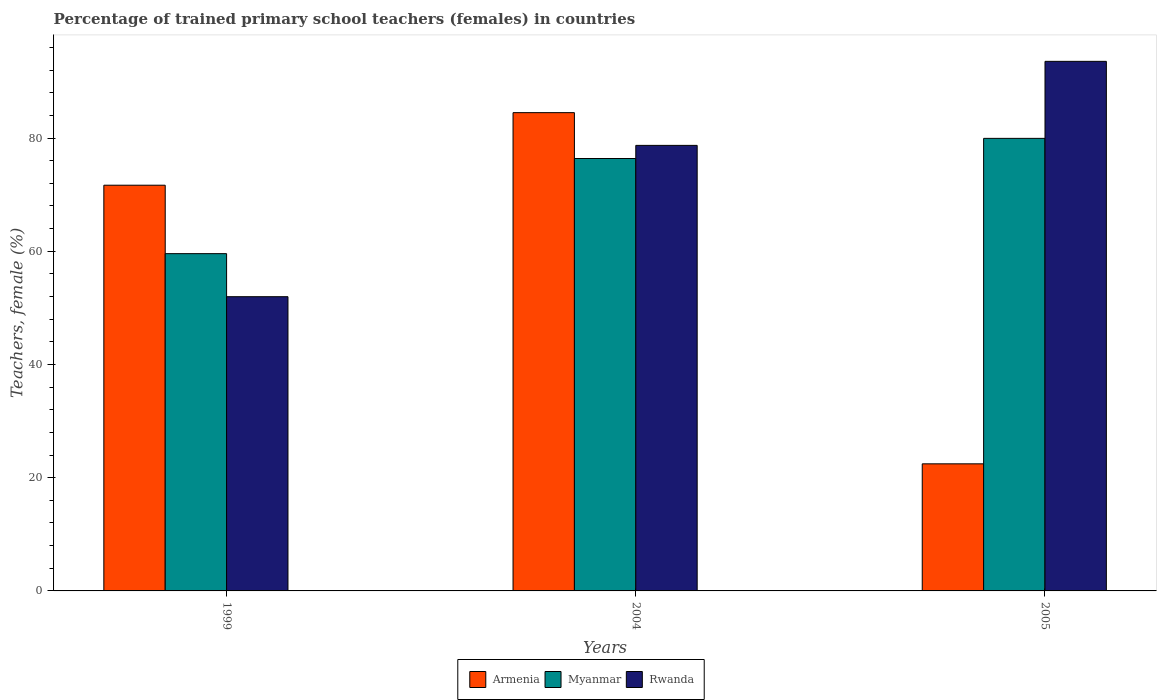How many different coloured bars are there?
Your answer should be compact. 3. Are the number of bars per tick equal to the number of legend labels?
Offer a very short reply. Yes. Are the number of bars on each tick of the X-axis equal?
Your response must be concise. Yes. How many bars are there on the 3rd tick from the left?
Provide a short and direct response. 3. What is the label of the 3rd group of bars from the left?
Provide a short and direct response. 2005. In how many cases, is the number of bars for a given year not equal to the number of legend labels?
Your answer should be compact. 0. What is the percentage of trained primary school teachers (females) in Armenia in 2005?
Provide a succinct answer. 22.45. Across all years, what is the maximum percentage of trained primary school teachers (females) in Armenia?
Give a very brief answer. 84.48. Across all years, what is the minimum percentage of trained primary school teachers (females) in Rwanda?
Provide a succinct answer. 51.97. In which year was the percentage of trained primary school teachers (females) in Rwanda maximum?
Offer a very short reply. 2005. In which year was the percentage of trained primary school teachers (females) in Myanmar minimum?
Provide a succinct answer. 1999. What is the total percentage of trained primary school teachers (females) in Armenia in the graph?
Your response must be concise. 178.6. What is the difference between the percentage of trained primary school teachers (females) in Myanmar in 1999 and that in 2004?
Make the answer very short. -16.81. What is the difference between the percentage of trained primary school teachers (females) in Rwanda in 2005 and the percentage of trained primary school teachers (females) in Armenia in 2004?
Make the answer very short. 9.06. What is the average percentage of trained primary school teachers (females) in Rwanda per year?
Make the answer very short. 74.74. In the year 2004, what is the difference between the percentage of trained primary school teachers (females) in Armenia and percentage of trained primary school teachers (females) in Rwanda?
Ensure brevity in your answer.  5.78. In how many years, is the percentage of trained primary school teachers (females) in Armenia greater than 20 %?
Keep it short and to the point. 3. What is the ratio of the percentage of trained primary school teachers (females) in Armenia in 1999 to that in 2004?
Keep it short and to the point. 0.85. Is the percentage of trained primary school teachers (females) in Armenia in 1999 less than that in 2005?
Your response must be concise. No. What is the difference between the highest and the second highest percentage of trained primary school teachers (females) in Myanmar?
Your response must be concise. 3.56. What is the difference between the highest and the lowest percentage of trained primary school teachers (females) in Myanmar?
Keep it short and to the point. 20.36. What does the 2nd bar from the left in 1999 represents?
Ensure brevity in your answer.  Myanmar. What does the 3rd bar from the right in 1999 represents?
Your answer should be compact. Armenia. How many bars are there?
Your answer should be compact. 9. How many legend labels are there?
Give a very brief answer. 3. What is the title of the graph?
Offer a terse response. Percentage of trained primary school teachers (females) in countries. Does "Macedonia" appear as one of the legend labels in the graph?
Your response must be concise. No. What is the label or title of the Y-axis?
Make the answer very short. Teachers, female (%). What is the Teachers, female (%) of Armenia in 1999?
Offer a very short reply. 71.67. What is the Teachers, female (%) of Myanmar in 1999?
Keep it short and to the point. 59.58. What is the Teachers, female (%) of Rwanda in 1999?
Ensure brevity in your answer.  51.97. What is the Teachers, female (%) in Armenia in 2004?
Give a very brief answer. 84.48. What is the Teachers, female (%) in Myanmar in 2004?
Offer a terse response. 76.38. What is the Teachers, female (%) in Rwanda in 2004?
Provide a succinct answer. 78.7. What is the Teachers, female (%) of Armenia in 2005?
Keep it short and to the point. 22.45. What is the Teachers, female (%) of Myanmar in 2005?
Your answer should be very brief. 79.94. What is the Teachers, female (%) of Rwanda in 2005?
Ensure brevity in your answer.  93.54. Across all years, what is the maximum Teachers, female (%) of Armenia?
Your answer should be compact. 84.48. Across all years, what is the maximum Teachers, female (%) in Myanmar?
Keep it short and to the point. 79.94. Across all years, what is the maximum Teachers, female (%) in Rwanda?
Make the answer very short. 93.54. Across all years, what is the minimum Teachers, female (%) in Armenia?
Offer a terse response. 22.45. Across all years, what is the minimum Teachers, female (%) of Myanmar?
Your answer should be very brief. 59.58. Across all years, what is the minimum Teachers, female (%) in Rwanda?
Your response must be concise. 51.97. What is the total Teachers, female (%) of Armenia in the graph?
Provide a short and direct response. 178.6. What is the total Teachers, female (%) in Myanmar in the graph?
Keep it short and to the point. 215.9. What is the total Teachers, female (%) of Rwanda in the graph?
Ensure brevity in your answer.  224.22. What is the difference between the Teachers, female (%) of Armenia in 1999 and that in 2004?
Provide a succinct answer. -12.82. What is the difference between the Teachers, female (%) of Myanmar in 1999 and that in 2004?
Provide a short and direct response. -16.81. What is the difference between the Teachers, female (%) of Rwanda in 1999 and that in 2004?
Keep it short and to the point. -26.73. What is the difference between the Teachers, female (%) in Armenia in 1999 and that in 2005?
Ensure brevity in your answer.  49.22. What is the difference between the Teachers, female (%) in Myanmar in 1999 and that in 2005?
Provide a succinct answer. -20.36. What is the difference between the Teachers, female (%) of Rwanda in 1999 and that in 2005?
Make the answer very short. -41.57. What is the difference between the Teachers, female (%) in Armenia in 2004 and that in 2005?
Provide a succinct answer. 62.03. What is the difference between the Teachers, female (%) in Myanmar in 2004 and that in 2005?
Your answer should be compact. -3.56. What is the difference between the Teachers, female (%) of Rwanda in 2004 and that in 2005?
Your response must be concise. -14.84. What is the difference between the Teachers, female (%) of Armenia in 1999 and the Teachers, female (%) of Myanmar in 2004?
Make the answer very short. -4.72. What is the difference between the Teachers, female (%) of Armenia in 1999 and the Teachers, female (%) of Rwanda in 2004?
Provide a short and direct response. -7.03. What is the difference between the Teachers, female (%) in Myanmar in 1999 and the Teachers, female (%) in Rwanda in 2004?
Your response must be concise. -19.12. What is the difference between the Teachers, female (%) of Armenia in 1999 and the Teachers, female (%) of Myanmar in 2005?
Provide a short and direct response. -8.27. What is the difference between the Teachers, female (%) in Armenia in 1999 and the Teachers, female (%) in Rwanda in 2005?
Your response must be concise. -21.88. What is the difference between the Teachers, female (%) of Myanmar in 1999 and the Teachers, female (%) of Rwanda in 2005?
Provide a short and direct response. -33.97. What is the difference between the Teachers, female (%) of Armenia in 2004 and the Teachers, female (%) of Myanmar in 2005?
Your response must be concise. 4.54. What is the difference between the Teachers, female (%) in Armenia in 2004 and the Teachers, female (%) in Rwanda in 2005?
Keep it short and to the point. -9.06. What is the difference between the Teachers, female (%) of Myanmar in 2004 and the Teachers, female (%) of Rwanda in 2005?
Provide a succinct answer. -17.16. What is the average Teachers, female (%) in Armenia per year?
Offer a terse response. 59.53. What is the average Teachers, female (%) in Myanmar per year?
Ensure brevity in your answer.  71.97. What is the average Teachers, female (%) of Rwanda per year?
Your answer should be very brief. 74.74. In the year 1999, what is the difference between the Teachers, female (%) of Armenia and Teachers, female (%) of Myanmar?
Offer a terse response. 12.09. In the year 1999, what is the difference between the Teachers, female (%) of Armenia and Teachers, female (%) of Rwanda?
Provide a succinct answer. 19.69. In the year 1999, what is the difference between the Teachers, female (%) of Myanmar and Teachers, female (%) of Rwanda?
Provide a short and direct response. 7.6. In the year 2004, what is the difference between the Teachers, female (%) of Armenia and Teachers, female (%) of Myanmar?
Ensure brevity in your answer.  8.1. In the year 2004, what is the difference between the Teachers, female (%) of Armenia and Teachers, female (%) of Rwanda?
Your answer should be very brief. 5.78. In the year 2004, what is the difference between the Teachers, female (%) of Myanmar and Teachers, female (%) of Rwanda?
Your answer should be very brief. -2.32. In the year 2005, what is the difference between the Teachers, female (%) of Armenia and Teachers, female (%) of Myanmar?
Your response must be concise. -57.49. In the year 2005, what is the difference between the Teachers, female (%) of Armenia and Teachers, female (%) of Rwanda?
Offer a very short reply. -71.1. In the year 2005, what is the difference between the Teachers, female (%) of Myanmar and Teachers, female (%) of Rwanda?
Give a very brief answer. -13.6. What is the ratio of the Teachers, female (%) of Armenia in 1999 to that in 2004?
Keep it short and to the point. 0.85. What is the ratio of the Teachers, female (%) in Myanmar in 1999 to that in 2004?
Make the answer very short. 0.78. What is the ratio of the Teachers, female (%) of Rwanda in 1999 to that in 2004?
Offer a very short reply. 0.66. What is the ratio of the Teachers, female (%) of Armenia in 1999 to that in 2005?
Keep it short and to the point. 3.19. What is the ratio of the Teachers, female (%) in Myanmar in 1999 to that in 2005?
Offer a very short reply. 0.75. What is the ratio of the Teachers, female (%) of Rwanda in 1999 to that in 2005?
Your answer should be compact. 0.56. What is the ratio of the Teachers, female (%) in Armenia in 2004 to that in 2005?
Provide a succinct answer. 3.76. What is the ratio of the Teachers, female (%) of Myanmar in 2004 to that in 2005?
Your answer should be compact. 0.96. What is the ratio of the Teachers, female (%) in Rwanda in 2004 to that in 2005?
Keep it short and to the point. 0.84. What is the difference between the highest and the second highest Teachers, female (%) of Armenia?
Provide a short and direct response. 12.82. What is the difference between the highest and the second highest Teachers, female (%) in Myanmar?
Offer a terse response. 3.56. What is the difference between the highest and the second highest Teachers, female (%) of Rwanda?
Your response must be concise. 14.84. What is the difference between the highest and the lowest Teachers, female (%) in Armenia?
Offer a very short reply. 62.03. What is the difference between the highest and the lowest Teachers, female (%) of Myanmar?
Keep it short and to the point. 20.36. What is the difference between the highest and the lowest Teachers, female (%) of Rwanda?
Ensure brevity in your answer.  41.57. 